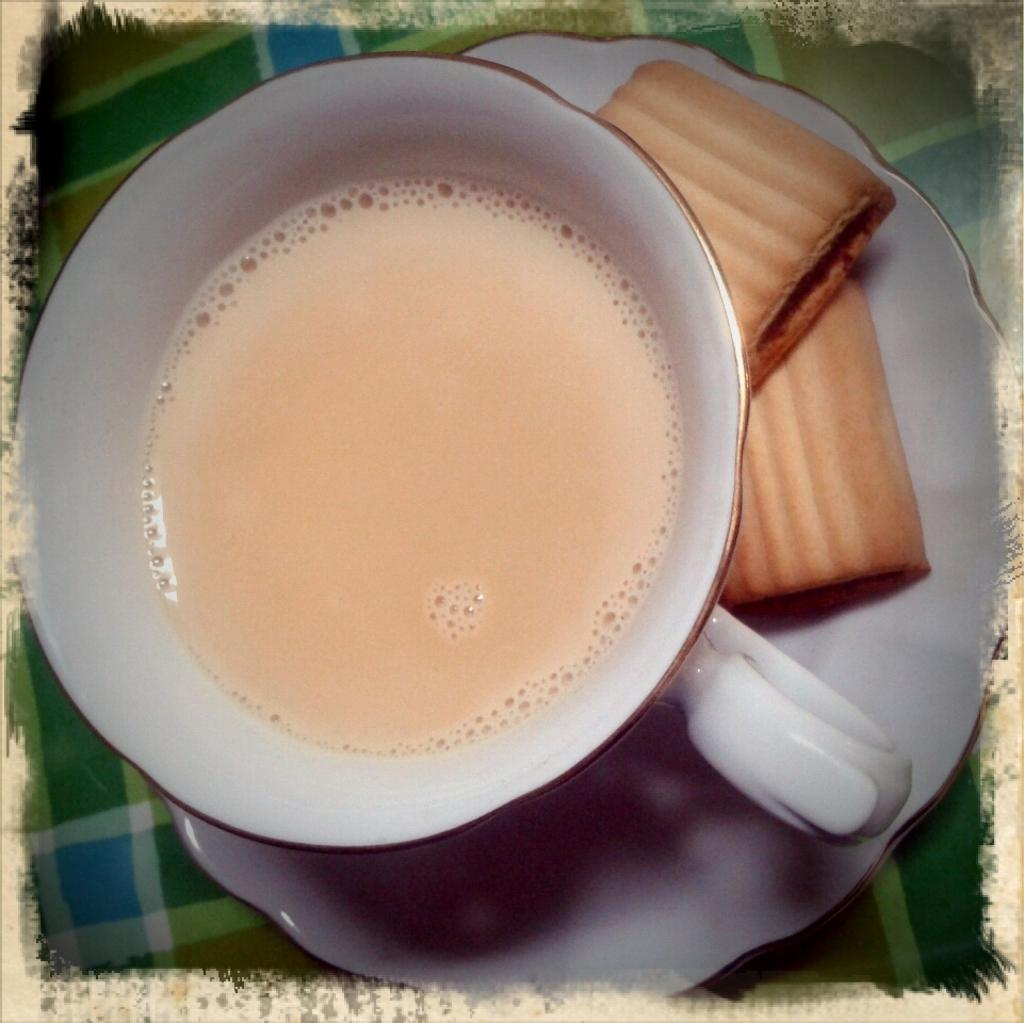What is on the saucer in the image? There are biscuits on the saucer in the image. What is the saucer associated with in the image? The saucer is associated with a cup of tea in the image. What type of beverage is in the cup in the image? There is a cup of tea in the image. What type of creature is shaking hands with the cup of tea in the image? There is no creature present in the image, and the cup of tea is not shaking hands with anyone. 